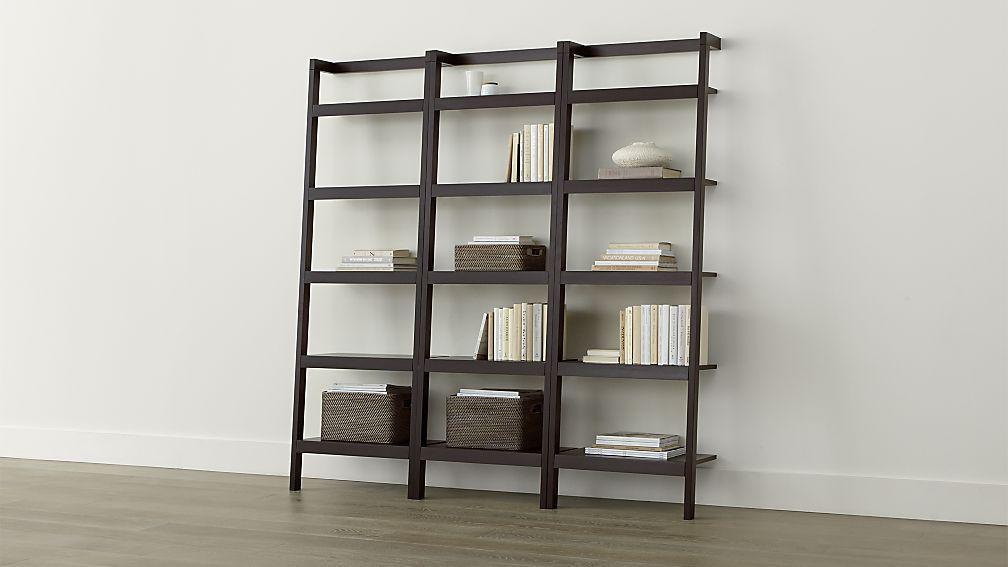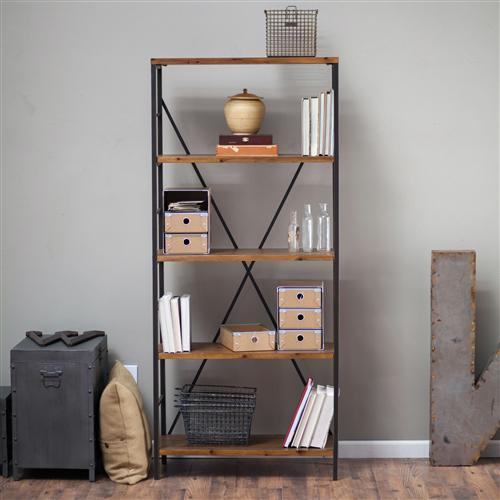The first image is the image on the left, the second image is the image on the right. For the images shown, is this caption "At least one bookcase has open shelves, no backboard to it." true? Answer yes or no. Yes. 